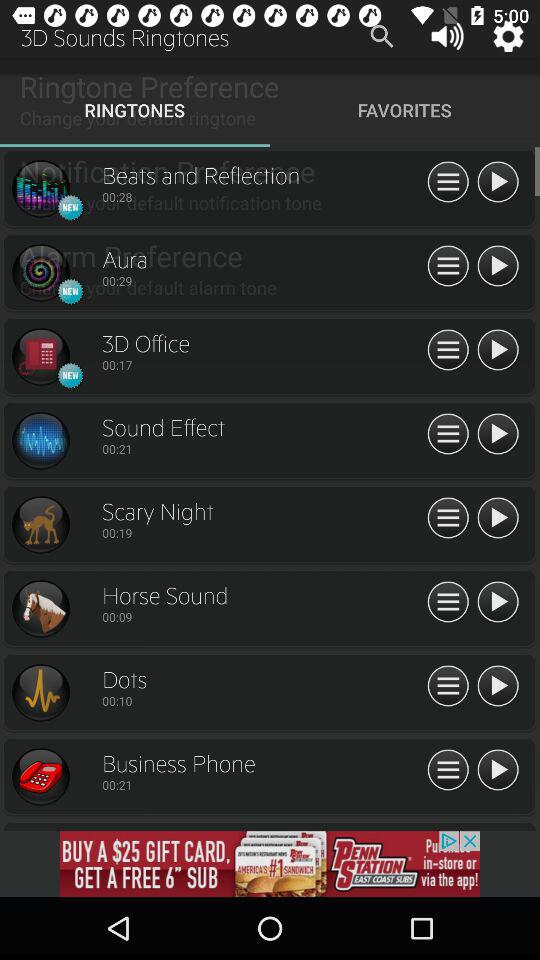What is the duration of the ringtone currently playing? The duration is 28 seconds. 